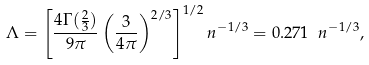Convert formula to latex. <formula><loc_0><loc_0><loc_500><loc_500>\Lambda = \left [ \frac { 4 \Gamma ( \frac { 2 } { 3 } ) } { 9 \pi } \left ( \frac { 3 } { 4 \pi } \right ) ^ { 2 / 3 } \right ] ^ { 1 / 2 } n ^ { - 1 / 3 } = 0 . 2 7 1 \ n ^ { - 1 / 3 } ,</formula> 